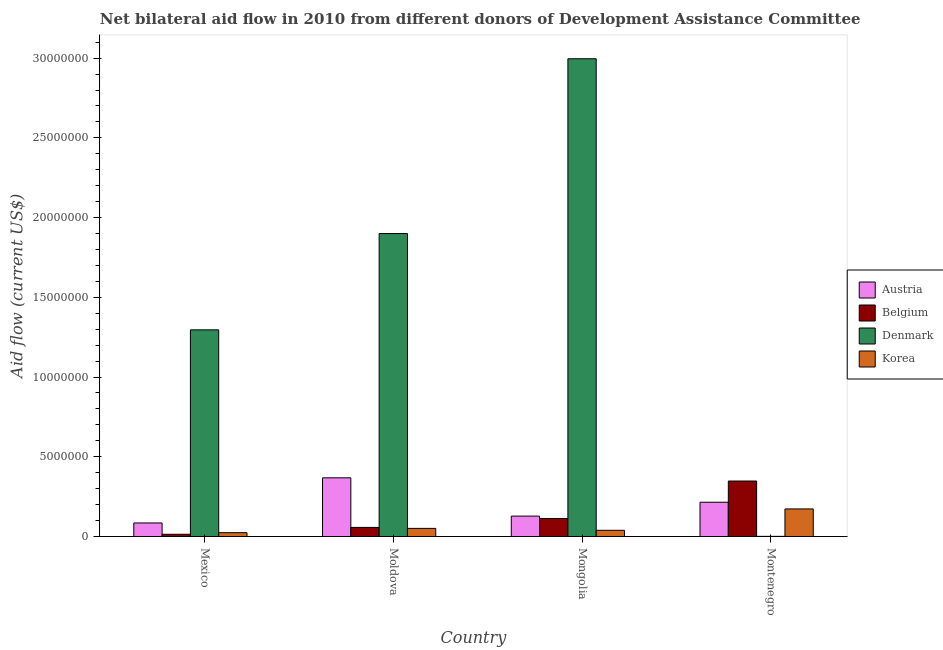How many different coloured bars are there?
Your answer should be very brief. 4. Are the number of bars per tick equal to the number of legend labels?
Offer a very short reply. Yes. Are the number of bars on each tick of the X-axis equal?
Provide a short and direct response. Yes. What is the label of the 2nd group of bars from the left?
Provide a short and direct response. Moldova. In how many cases, is the number of bars for a given country not equal to the number of legend labels?
Provide a short and direct response. 0. What is the amount of aid given by korea in Montenegro?
Offer a terse response. 1.73e+06. Across all countries, what is the maximum amount of aid given by denmark?
Give a very brief answer. 3.00e+07. Across all countries, what is the minimum amount of aid given by denmark?
Your answer should be very brief. 10000. In which country was the amount of aid given by denmark maximum?
Offer a terse response. Mongolia. What is the total amount of aid given by austria in the graph?
Keep it short and to the point. 7.96e+06. What is the difference between the amount of aid given by austria in Mexico and that in Moldova?
Provide a short and direct response. -2.83e+06. What is the difference between the amount of aid given by austria in Mexico and the amount of aid given by belgium in Moldova?
Provide a succinct answer. 2.80e+05. What is the average amount of aid given by austria per country?
Ensure brevity in your answer.  1.99e+06. What is the difference between the amount of aid given by denmark and amount of aid given by korea in Mexico?
Your answer should be compact. 1.27e+07. What is the ratio of the amount of aid given by korea in Mexico to that in Mongolia?
Your response must be concise. 0.62. Is the amount of aid given by belgium in Mexico less than that in Mongolia?
Your answer should be compact. Yes. Is the difference between the amount of aid given by belgium in Mongolia and Montenegro greater than the difference between the amount of aid given by korea in Mongolia and Montenegro?
Offer a very short reply. No. What is the difference between the highest and the second highest amount of aid given by denmark?
Ensure brevity in your answer.  1.10e+07. What is the difference between the highest and the lowest amount of aid given by denmark?
Make the answer very short. 3.00e+07. In how many countries, is the amount of aid given by korea greater than the average amount of aid given by korea taken over all countries?
Ensure brevity in your answer.  1. Is it the case that in every country, the sum of the amount of aid given by austria and amount of aid given by belgium is greater than the sum of amount of aid given by korea and amount of aid given by denmark?
Ensure brevity in your answer.  No. What does the 3rd bar from the left in Mongolia represents?
Give a very brief answer. Denmark. What does the 3rd bar from the right in Moldova represents?
Offer a terse response. Belgium. Are all the bars in the graph horizontal?
Your answer should be compact. No. How many countries are there in the graph?
Your answer should be very brief. 4. Does the graph contain grids?
Your response must be concise. No. Where does the legend appear in the graph?
Make the answer very short. Center right. How many legend labels are there?
Provide a short and direct response. 4. What is the title of the graph?
Make the answer very short. Net bilateral aid flow in 2010 from different donors of Development Assistance Committee. Does "Methodology assessment" appear as one of the legend labels in the graph?
Keep it short and to the point. No. What is the label or title of the X-axis?
Provide a succinct answer. Country. What is the label or title of the Y-axis?
Your answer should be compact. Aid flow (current US$). What is the Aid flow (current US$) of Austria in Mexico?
Offer a very short reply. 8.50e+05. What is the Aid flow (current US$) in Denmark in Mexico?
Offer a terse response. 1.30e+07. What is the Aid flow (current US$) in Korea in Mexico?
Give a very brief answer. 2.40e+05. What is the Aid flow (current US$) of Austria in Moldova?
Ensure brevity in your answer.  3.68e+06. What is the Aid flow (current US$) in Belgium in Moldova?
Make the answer very short. 5.70e+05. What is the Aid flow (current US$) in Denmark in Moldova?
Make the answer very short. 1.90e+07. What is the Aid flow (current US$) in Korea in Moldova?
Your answer should be very brief. 5.10e+05. What is the Aid flow (current US$) in Austria in Mongolia?
Give a very brief answer. 1.28e+06. What is the Aid flow (current US$) of Belgium in Mongolia?
Ensure brevity in your answer.  1.13e+06. What is the Aid flow (current US$) in Denmark in Mongolia?
Offer a terse response. 3.00e+07. What is the Aid flow (current US$) of Austria in Montenegro?
Your answer should be compact. 2.15e+06. What is the Aid flow (current US$) in Belgium in Montenegro?
Make the answer very short. 3.48e+06. What is the Aid flow (current US$) in Korea in Montenegro?
Your answer should be compact. 1.73e+06. Across all countries, what is the maximum Aid flow (current US$) in Austria?
Your answer should be compact. 3.68e+06. Across all countries, what is the maximum Aid flow (current US$) in Belgium?
Offer a terse response. 3.48e+06. Across all countries, what is the maximum Aid flow (current US$) in Denmark?
Ensure brevity in your answer.  3.00e+07. Across all countries, what is the maximum Aid flow (current US$) in Korea?
Give a very brief answer. 1.73e+06. Across all countries, what is the minimum Aid flow (current US$) of Austria?
Ensure brevity in your answer.  8.50e+05. Across all countries, what is the minimum Aid flow (current US$) in Korea?
Offer a terse response. 2.40e+05. What is the total Aid flow (current US$) in Austria in the graph?
Make the answer very short. 7.96e+06. What is the total Aid flow (current US$) of Belgium in the graph?
Your response must be concise. 5.32e+06. What is the total Aid flow (current US$) of Denmark in the graph?
Offer a very short reply. 6.19e+07. What is the total Aid flow (current US$) in Korea in the graph?
Ensure brevity in your answer.  2.87e+06. What is the difference between the Aid flow (current US$) in Austria in Mexico and that in Moldova?
Give a very brief answer. -2.83e+06. What is the difference between the Aid flow (current US$) in Belgium in Mexico and that in Moldova?
Give a very brief answer. -4.30e+05. What is the difference between the Aid flow (current US$) in Denmark in Mexico and that in Moldova?
Offer a very short reply. -6.04e+06. What is the difference between the Aid flow (current US$) of Austria in Mexico and that in Mongolia?
Your response must be concise. -4.30e+05. What is the difference between the Aid flow (current US$) of Belgium in Mexico and that in Mongolia?
Your answer should be very brief. -9.90e+05. What is the difference between the Aid flow (current US$) of Denmark in Mexico and that in Mongolia?
Your response must be concise. -1.70e+07. What is the difference between the Aid flow (current US$) in Korea in Mexico and that in Mongolia?
Provide a short and direct response. -1.50e+05. What is the difference between the Aid flow (current US$) in Austria in Mexico and that in Montenegro?
Provide a succinct answer. -1.30e+06. What is the difference between the Aid flow (current US$) in Belgium in Mexico and that in Montenegro?
Your answer should be very brief. -3.34e+06. What is the difference between the Aid flow (current US$) in Denmark in Mexico and that in Montenegro?
Your answer should be compact. 1.30e+07. What is the difference between the Aid flow (current US$) of Korea in Mexico and that in Montenegro?
Provide a succinct answer. -1.49e+06. What is the difference between the Aid flow (current US$) of Austria in Moldova and that in Mongolia?
Provide a succinct answer. 2.40e+06. What is the difference between the Aid flow (current US$) of Belgium in Moldova and that in Mongolia?
Provide a short and direct response. -5.60e+05. What is the difference between the Aid flow (current US$) in Denmark in Moldova and that in Mongolia?
Offer a terse response. -1.10e+07. What is the difference between the Aid flow (current US$) of Korea in Moldova and that in Mongolia?
Provide a succinct answer. 1.20e+05. What is the difference between the Aid flow (current US$) in Austria in Moldova and that in Montenegro?
Offer a terse response. 1.53e+06. What is the difference between the Aid flow (current US$) in Belgium in Moldova and that in Montenegro?
Offer a terse response. -2.91e+06. What is the difference between the Aid flow (current US$) in Denmark in Moldova and that in Montenegro?
Ensure brevity in your answer.  1.90e+07. What is the difference between the Aid flow (current US$) in Korea in Moldova and that in Montenegro?
Provide a short and direct response. -1.22e+06. What is the difference between the Aid flow (current US$) of Austria in Mongolia and that in Montenegro?
Your answer should be compact. -8.70e+05. What is the difference between the Aid flow (current US$) in Belgium in Mongolia and that in Montenegro?
Your answer should be compact. -2.35e+06. What is the difference between the Aid flow (current US$) of Denmark in Mongolia and that in Montenegro?
Keep it short and to the point. 3.00e+07. What is the difference between the Aid flow (current US$) of Korea in Mongolia and that in Montenegro?
Make the answer very short. -1.34e+06. What is the difference between the Aid flow (current US$) of Austria in Mexico and the Aid flow (current US$) of Denmark in Moldova?
Make the answer very short. -1.82e+07. What is the difference between the Aid flow (current US$) of Austria in Mexico and the Aid flow (current US$) of Korea in Moldova?
Your answer should be compact. 3.40e+05. What is the difference between the Aid flow (current US$) of Belgium in Mexico and the Aid flow (current US$) of Denmark in Moldova?
Keep it short and to the point. -1.89e+07. What is the difference between the Aid flow (current US$) of Belgium in Mexico and the Aid flow (current US$) of Korea in Moldova?
Keep it short and to the point. -3.70e+05. What is the difference between the Aid flow (current US$) of Denmark in Mexico and the Aid flow (current US$) of Korea in Moldova?
Provide a succinct answer. 1.24e+07. What is the difference between the Aid flow (current US$) in Austria in Mexico and the Aid flow (current US$) in Belgium in Mongolia?
Offer a very short reply. -2.80e+05. What is the difference between the Aid flow (current US$) in Austria in Mexico and the Aid flow (current US$) in Denmark in Mongolia?
Offer a very short reply. -2.91e+07. What is the difference between the Aid flow (current US$) in Belgium in Mexico and the Aid flow (current US$) in Denmark in Mongolia?
Offer a very short reply. -2.98e+07. What is the difference between the Aid flow (current US$) in Denmark in Mexico and the Aid flow (current US$) in Korea in Mongolia?
Keep it short and to the point. 1.26e+07. What is the difference between the Aid flow (current US$) of Austria in Mexico and the Aid flow (current US$) of Belgium in Montenegro?
Keep it short and to the point. -2.63e+06. What is the difference between the Aid flow (current US$) in Austria in Mexico and the Aid flow (current US$) in Denmark in Montenegro?
Offer a very short reply. 8.40e+05. What is the difference between the Aid flow (current US$) of Austria in Mexico and the Aid flow (current US$) of Korea in Montenegro?
Your response must be concise. -8.80e+05. What is the difference between the Aid flow (current US$) of Belgium in Mexico and the Aid flow (current US$) of Korea in Montenegro?
Make the answer very short. -1.59e+06. What is the difference between the Aid flow (current US$) in Denmark in Mexico and the Aid flow (current US$) in Korea in Montenegro?
Provide a succinct answer. 1.12e+07. What is the difference between the Aid flow (current US$) of Austria in Moldova and the Aid flow (current US$) of Belgium in Mongolia?
Your response must be concise. 2.55e+06. What is the difference between the Aid flow (current US$) of Austria in Moldova and the Aid flow (current US$) of Denmark in Mongolia?
Your answer should be very brief. -2.63e+07. What is the difference between the Aid flow (current US$) of Austria in Moldova and the Aid flow (current US$) of Korea in Mongolia?
Provide a short and direct response. 3.29e+06. What is the difference between the Aid flow (current US$) of Belgium in Moldova and the Aid flow (current US$) of Denmark in Mongolia?
Offer a terse response. -2.94e+07. What is the difference between the Aid flow (current US$) of Belgium in Moldova and the Aid flow (current US$) of Korea in Mongolia?
Offer a terse response. 1.80e+05. What is the difference between the Aid flow (current US$) of Denmark in Moldova and the Aid flow (current US$) of Korea in Mongolia?
Provide a succinct answer. 1.86e+07. What is the difference between the Aid flow (current US$) of Austria in Moldova and the Aid flow (current US$) of Denmark in Montenegro?
Give a very brief answer. 3.67e+06. What is the difference between the Aid flow (current US$) in Austria in Moldova and the Aid flow (current US$) in Korea in Montenegro?
Make the answer very short. 1.95e+06. What is the difference between the Aid flow (current US$) in Belgium in Moldova and the Aid flow (current US$) in Denmark in Montenegro?
Your answer should be very brief. 5.60e+05. What is the difference between the Aid flow (current US$) of Belgium in Moldova and the Aid flow (current US$) of Korea in Montenegro?
Your answer should be very brief. -1.16e+06. What is the difference between the Aid flow (current US$) of Denmark in Moldova and the Aid flow (current US$) of Korea in Montenegro?
Provide a succinct answer. 1.73e+07. What is the difference between the Aid flow (current US$) of Austria in Mongolia and the Aid flow (current US$) of Belgium in Montenegro?
Offer a very short reply. -2.20e+06. What is the difference between the Aid flow (current US$) of Austria in Mongolia and the Aid flow (current US$) of Denmark in Montenegro?
Offer a very short reply. 1.27e+06. What is the difference between the Aid flow (current US$) of Austria in Mongolia and the Aid flow (current US$) of Korea in Montenegro?
Make the answer very short. -4.50e+05. What is the difference between the Aid flow (current US$) in Belgium in Mongolia and the Aid flow (current US$) in Denmark in Montenegro?
Your answer should be very brief. 1.12e+06. What is the difference between the Aid flow (current US$) of Belgium in Mongolia and the Aid flow (current US$) of Korea in Montenegro?
Provide a succinct answer. -6.00e+05. What is the difference between the Aid flow (current US$) in Denmark in Mongolia and the Aid flow (current US$) in Korea in Montenegro?
Offer a terse response. 2.82e+07. What is the average Aid flow (current US$) in Austria per country?
Make the answer very short. 1.99e+06. What is the average Aid flow (current US$) of Belgium per country?
Your answer should be compact. 1.33e+06. What is the average Aid flow (current US$) in Denmark per country?
Ensure brevity in your answer.  1.55e+07. What is the average Aid flow (current US$) of Korea per country?
Provide a short and direct response. 7.18e+05. What is the difference between the Aid flow (current US$) of Austria and Aid flow (current US$) of Belgium in Mexico?
Your answer should be very brief. 7.10e+05. What is the difference between the Aid flow (current US$) in Austria and Aid flow (current US$) in Denmark in Mexico?
Your answer should be very brief. -1.21e+07. What is the difference between the Aid flow (current US$) in Austria and Aid flow (current US$) in Korea in Mexico?
Provide a succinct answer. 6.10e+05. What is the difference between the Aid flow (current US$) of Belgium and Aid flow (current US$) of Denmark in Mexico?
Your response must be concise. -1.28e+07. What is the difference between the Aid flow (current US$) of Denmark and Aid flow (current US$) of Korea in Mexico?
Your answer should be very brief. 1.27e+07. What is the difference between the Aid flow (current US$) in Austria and Aid flow (current US$) in Belgium in Moldova?
Provide a succinct answer. 3.11e+06. What is the difference between the Aid flow (current US$) in Austria and Aid flow (current US$) in Denmark in Moldova?
Provide a short and direct response. -1.53e+07. What is the difference between the Aid flow (current US$) of Austria and Aid flow (current US$) of Korea in Moldova?
Provide a succinct answer. 3.17e+06. What is the difference between the Aid flow (current US$) in Belgium and Aid flow (current US$) in Denmark in Moldova?
Offer a terse response. -1.84e+07. What is the difference between the Aid flow (current US$) of Denmark and Aid flow (current US$) of Korea in Moldova?
Keep it short and to the point. 1.85e+07. What is the difference between the Aid flow (current US$) in Austria and Aid flow (current US$) in Belgium in Mongolia?
Give a very brief answer. 1.50e+05. What is the difference between the Aid flow (current US$) of Austria and Aid flow (current US$) of Denmark in Mongolia?
Offer a terse response. -2.87e+07. What is the difference between the Aid flow (current US$) of Austria and Aid flow (current US$) of Korea in Mongolia?
Your response must be concise. 8.90e+05. What is the difference between the Aid flow (current US$) in Belgium and Aid flow (current US$) in Denmark in Mongolia?
Your response must be concise. -2.88e+07. What is the difference between the Aid flow (current US$) in Belgium and Aid flow (current US$) in Korea in Mongolia?
Make the answer very short. 7.40e+05. What is the difference between the Aid flow (current US$) in Denmark and Aid flow (current US$) in Korea in Mongolia?
Give a very brief answer. 2.96e+07. What is the difference between the Aid flow (current US$) in Austria and Aid flow (current US$) in Belgium in Montenegro?
Provide a succinct answer. -1.33e+06. What is the difference between the Aid flow (current US$) in Austria and Aid flow (current US$) in Denmark in Montenegro?
Make the answer very short. 2.14e+06. What is the difference between the Aid flow (current US$) of Austria and Aid flow (current US$) of Korea in Montenegro?
Make the answer very short. 4.20e+05. What is the difference between the Aid flow (current US$) of Belgium and Aid flow (current US$) of Denmark in Montenegro?
Provide a short and direct response. 3.47e+06. What is the difference between the Aid flow (current US$) of Belgium and Aid flow (current US$) of Korea in Montenegro?
Provide a succinct answer. 1.75e+06. What is the difference between the Aid flow (current US$) in Denmark and Aid flow (current US$) in Korea in Montenegro?
Ensure brevity in your answer.  -1.72e+06. What is the ratio of the Aid flow (current US$) of Austria in Mexico to that in Moldova?
Ensure brevity in your answer.  0.23. What is the ratio of the Aid flow (current US$) in Belgium in Mexico to that in Moldova?
Offer a terse response. 0.25. What is the ratio of the Aid flow (current US$) of Denmark in Mexico to that in Moldova?
Make the answer very short. 0.68. What is the ratio of the Aid flow (current US$) in Korea in Mexico to that in Moldova?
Offer a very short reply. 0.47. What is the ratio of the Aid flow (current US$) in Austria in Mexico to that in Mongolia?
Provide a short and direct response. 0.66. What is the ratio of the Aid flow (current US$) in Belgium in Mexico to that in Mongolia?
Your answer should be very brief. 0.12. What is the ratio of the Aid flow (current US$) in Denmark in Mexico to that in Mongolia?
Offer a terse response. 0.43. What is the ratio of the Aid flow (current US$) of Korea in Mexico to that in Mongolia?
Your response must be concise. 0.62. What is the ratio of the Aid flow (current US$) of Austria in Mexico to that in Montenegro?
Your answer should be very brief. 0.4. What is the ratio of the Aid flow (current US$) in Belgium in Mexico to that in Montenegro?
Give a very brief answer. 0.04. What is the ratio of the Aid flow (current US$) of Denmark in Mexico to that in Montenegro?
Provide a short and direct response. 1296. What is the ratio of the Aid flow (current US$) in Korea in Mexico to that in Montenegro?
Make the answer very short. 0.14. What is the ratio of the Aid flow (current US$) of Austria in Moldova to that in Mongolia?
Your answer should be compact. 2.88. What is the ratio of the Aid flow (current US$) of Belgium in Moldova to that in Mongolia?
Your answer should be compact. 0.5. What is the ratio of the Aid flow (current US$) of Denmark in Moldova to that in Mongolia?
Give a very brief answer. 0.63. What is the ratio of the Aid flow (current US$) in Korea in Moldova to that in Mongolia?
Keep it short and to the point. 1.31. What is the ratio of the Aid flow (current US$) of Austria in Moldova to that in Montenegro?
Offer a very short reply. 1.71. What is the ratio of the Aid flow (current US$) in Belgium in Moldova to that in Montenegro?
Your answer should be compact. 0.16. What is the ratio of the Aid flow (current US$) in Denmark in Moldova to that in Montenegro?
Your response must be concise. 1900. What is the ratio of the Aid flow (current US$) of Korea in Moldova to that in Montenegro?
Give a very brief answer. 0.29. What is the ratio of the Aid flow (current US$) of Austria in Mongolia to that in Montenegro?
Offer a terse response. 0.6. What is the ratio of the Aid flow (current US$) of Belgium in Mongolia to that in Montenegro?
Offer a terse response. 0.32. What is the ratio of the Aid flow (current US$) of Denmark in Mongolia to that in Montenegro?
Your response must be concise. 2996. What is the ratio of the Aid flow (current US$) of Korea in Mongolia to that in Montenegro?
Provide a succinct answer. 0.23. What is the difference between the highest and the second highest Aid flow (current US$) of Austria?
Provide a succinct answer. 1.53e+06. What is the difference between the highest and the second highest Aid flow (current US$) in Belgium?
Your answer should be compact. 2.35e+06. What is the difference between the highest and the second highest Aid flow (current US$) in Denmark?
Your answer should be compact. 1.10e+07. What is the difference between the highest and the second highest Aid flow (current US$) in Korea?
Give a very brief answer. 1.22e+06. What is the difference between the highest and the lowest Aid flow (current US$) in Austria?
Your answer should be very brief. 2.83e+06. What is the difference between the highest and the lowest Aid flow (current US$) of Belgium?
Offer a very short reply. 3.34e+06. What is the difference between the highest and the lowest Aid flow (current US$) in Denmark?
Your answer should be compact. 3.00e+07. What is the difference between the highest and the lowest Aid flow (current US$) of Korea?
Make the answer very short. 1.49e+06. 